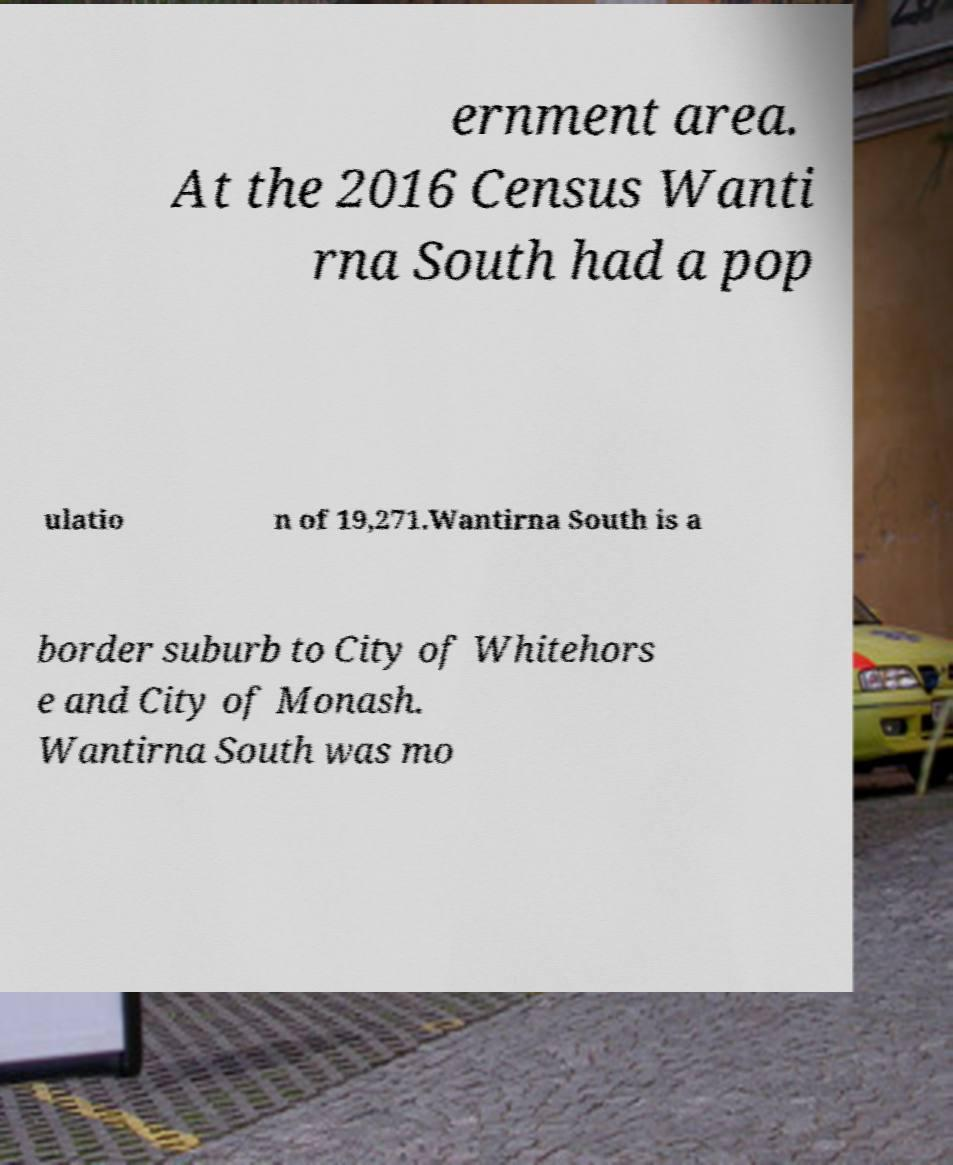Could you extract and type out the text from this image? ernment area. At the 2016 Census Wanti rna South had a pop ulatio n of 19,271.Wantirna South is a border suburb to City of Whitehors e and City of Monash. Wantirna South was mo 